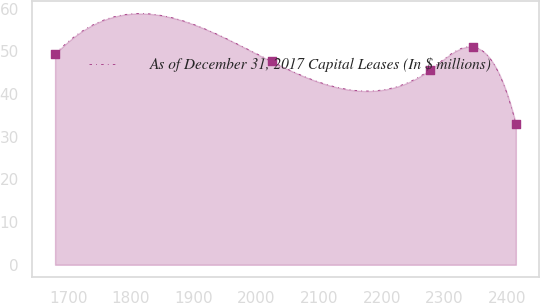Convert chart to OTSL. <chart><loc_0><loc_0><loc_500><loc_500><line_chart><ecel><fcel>As of December 31, 2017 Capital Leases (In $ millions)<nl><fcel>1679.2<fcel>49.37<nl><fcel>2024.17<fcel>47.65<nl><fcel>2276.34<fcel>45.67<nl><fcel>2344.86<fcel>51.09<nl><fcel>2413.38<fcel>33.06<nl></chart> 